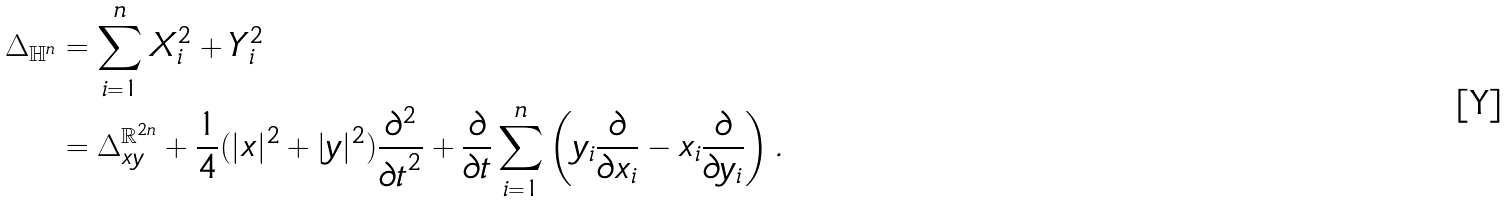<formula> <loc_0><loc_0><loc_500><loc_500>\Delta _ { \mathbb { H } ^ { n } } & = \sum _ { i = 1 } ^ { n } X _ { i } ^ { 2 } + Y _ { i } ^ { 2 } \\ & = \Delta ^ { \mathbb { R } ^ { 2 n } } _ { x y } + \frac { 1 } { 4 } ( | x | ^ { 2 } + | y | ^ { 2 } ) \frac { \partial ^ { 2 } } { { \partial t } ^ { 2 } } + \frac { \partial } { \partial t } \sum _ { i = 1 } ^ { n } \left ( y _ { i } \frac { \partial } { \partial x _ { i } } - x _ { i } \frac { \partial } { \partial y _ { i } } \right ) .</formula> 